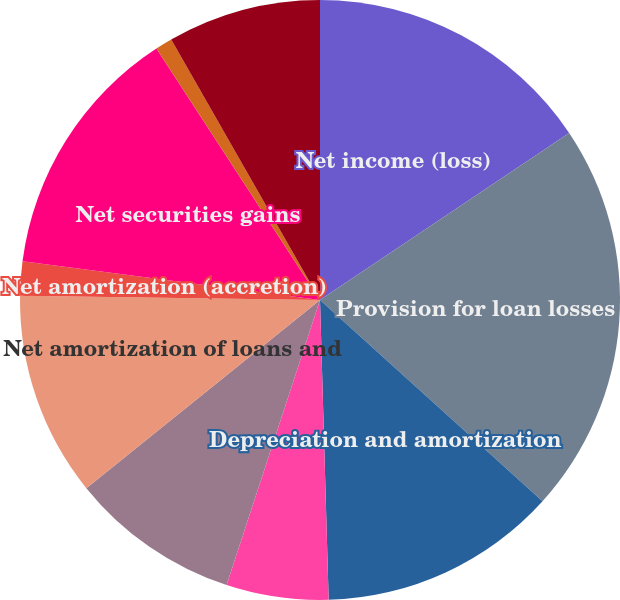Convert chart. <chart><loc_0><loc_0><loc_500><loc_500><pie_chart><fcel>Net income (loss)<fcel>Provision for loan losses<fcel>Depreciation and amortization<fcel>Provision for losses on other<fcel>Net amortization of securities<fcel>Net amortization of loans and<fcel>Net amortization (accretion)<fcel>Net securities gains<fcel>Other-than-temporary<fcel>Deferred income tax (benefit)<nl><fcel>15.6%<fcel>21.1%<fcel>12.84%<fcel>5.5%<fcel>9.17%<fcel>11.01%<fcel>1.84%<fcel>13.76%<fcel>0.92%<fcel>8.26%<nl></chart> 